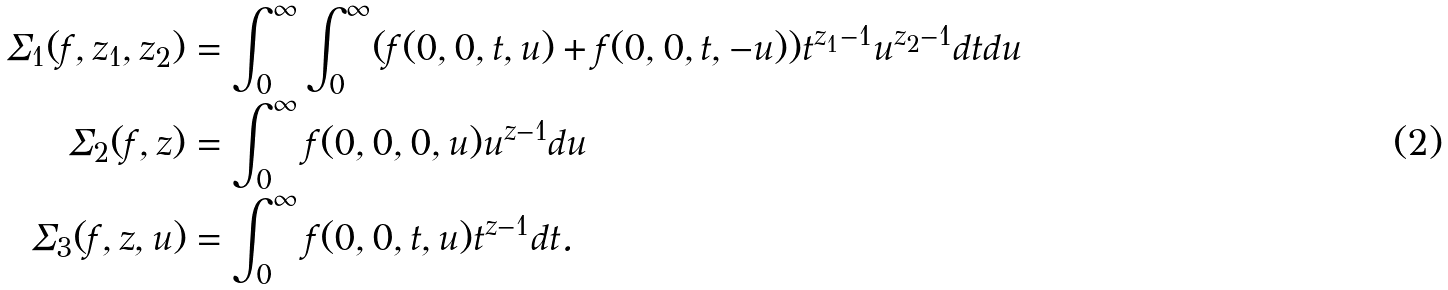Convert formula to latex. <formula><loc_0><loc_0><loc_500><loc_500>\Sigma _ { 1 } ( f , z _ { 1 } , z _ { 2 } ) & = \int _ { 0 } ^ { \infty } \int _ { 0 } ^ { \infty } ( f ( 0 , 0 , t , u ) + f ( 0 , 0 , t , - u ) ) t ^ { z _ { 1 } - 1 } u ^ { z _ { 2 } - 1 } d t d u \\ \Sigma _ { 2 } ( f , z ) & = \int _ { 0 } ^ { \infty } f ( 0 , 0 , 0 , u ) u ^ { z - 1 } d u \\ \Sigma _ { 3 } ( f , z , u ) & = \int _ { 0 } ^ { \infty } f ( 0 , 0 , t , u ) t ^ { z - 1 } d t .</formula> 